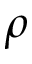Convert formula to latex. <formula><loc_0><loc_0><loc_500><loc_500>\rho</formula> 